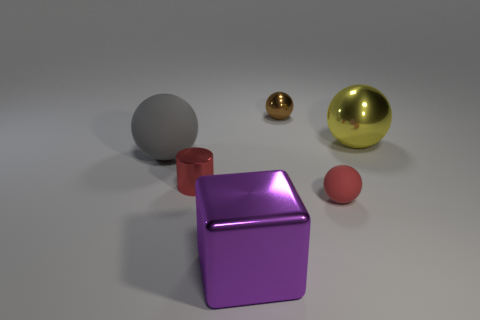Add 1 large metallic spheres. How many objects exist? 7 Subtract all cubes. How many objects are left? 5 Subtract all green metallic things. Subtract all small balls. How many objects are left? 4 Add 1 red objects. How many red objects are left? 3 Add 5 gray cylinders. How many gray cylinders exist? 5 Subtract 1 yellow spheres. How many objects are left? 5 